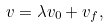Convert formula to latex. <formula><loc_0><loc_0><loc_500><loc_500>v = \lambda v _ { 0 } + v _ { f } ,</formula> 